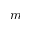Convert formula to latex. <formula><loc_0><loc_0><loc_500><loc_500>m</formula> 